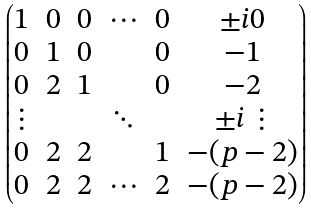Convert formula to latex. <formula><loc_0><loc_0><loc_500><loc_500>\begin{pmatrix} 1 & 0 & 0 & \cdots & 0 & \pm i 0 \\ 0 & 1 & 0 & & 0 & - 1 \\ 0 & 2 & 1 & & 0 & - 2 \\ \vdots & & & \ddots & & \pm i \vdots \\ 0 & 2 & 2 & & 1 & - ( p - 2 ) \\ 0 & 2 & 2 & \cdots & 2 & - ( p - 2 ) \end{pmatrix}</formula> 